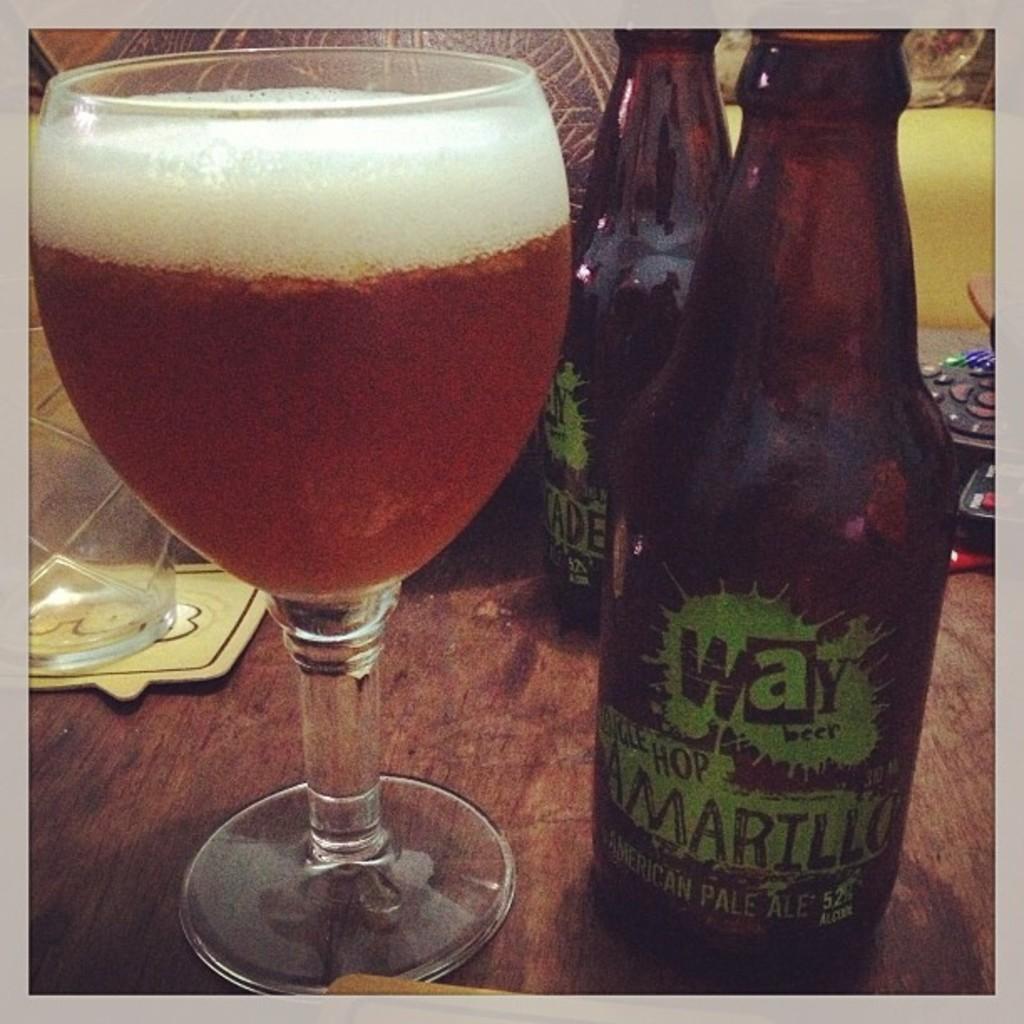What is the word starting with a "w" on the bottle?
Provide a short and direct response. Way. 